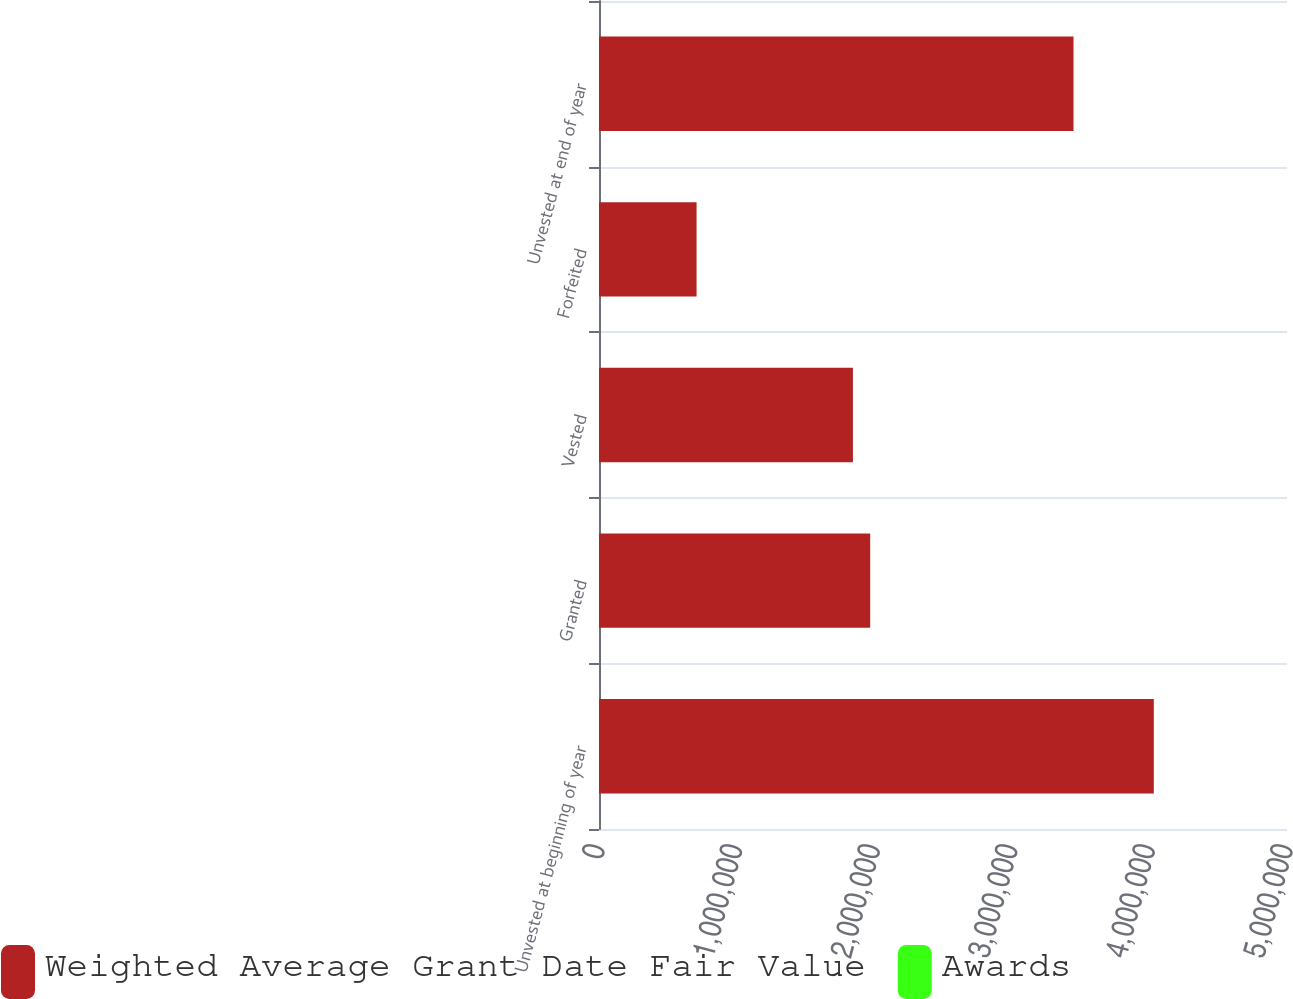Convert chart to OTSL. <chart><loc_0><loc_0><loc_500><loc_500><stacked_bar_chart><ecel><fcel>Unvested at beginning of year<fcel>Granted<fcel>Vested<fcel>Forfeited<fcel>Unvested at end of year<nl><fcel>Weighted Average Grant Date Fair Value<fcel>4.03189e+06<fcel>1.97088e+06<fcel>1.84533e+06<fcel>709088<fcel>3.44835e+06<nl><fcel>Awards<fcel>31.8<fcel>34.98<fcel>30.64<fcel>32.73<fcel>34.04<nl></chart> 